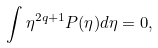<formula> <loc_0><loc_0><loc_500><loc_500>\int \eta ^ { 2 q + 1 } P ( \eta ) d \eta = 0 ,</formula> 